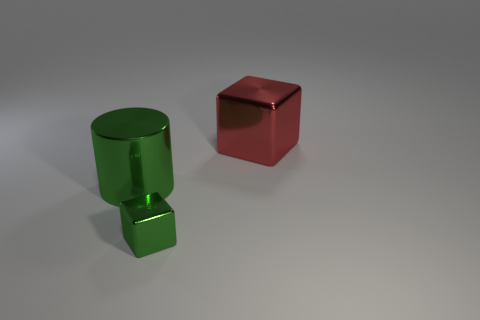Is there any other thing that has the same size as the green metal cube?
Your answer should be very brief. No. Are there more big things that are in front of the big shiny cylinder than big green metal cylinders that are on the right side of the red object?
Your answer should be very brief. No. What is the color of the large thing that is to the left of the green cube?
Offer a terse response. Green. Are there any other green things of the same shape as the big green metal thing?
Keep it short and to the point. No. How many red things are shiny cylinders or large objects?
Your answer should be compact. 1. Are there any green metallic cylinders of the same size as the red metal object?
Offer a very short reply. Yes. What number of big matte cylinders are there?
Your answer should be compact. 0. How many tiny things are either brown cubes or green objects?
Make the answer very short. 1. What color is the metallic cube that is behind the thing in front of the thing that is left of the tiny green metallic cube?
Offer a terse response. Red. How many other things are there of the same color as the big metal block?
Your response must be concise. 0. 